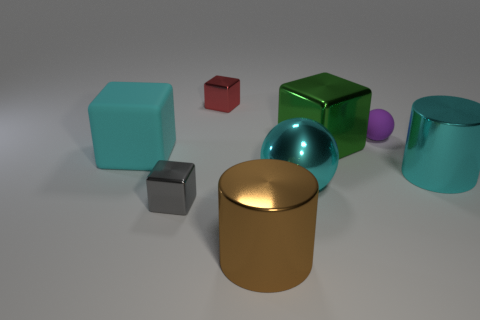Subtract all red blocks. How many blocks are left? 3 Subtract all green cubes. How many cubes are left? 3 Subtract all cylinders. How many objects are left? 6 Add 4 tiny cubes. How many tiny cubes are left? 6 Add 2 large brown cylinders. How many large brown cylinders exist? 3 Add 1 tiny cyan metal cylinders. How many objects exist? 9 Subtract 1 cyan cylinders. How many objects are left? 7 Subtract 2 balls. How many balls are left? 0 Subtract all yellow cylinders. Subtract all brown spheres. How many cylinders are left? 2 Subtract all blue spheres. How many gray blocks are left? 1 